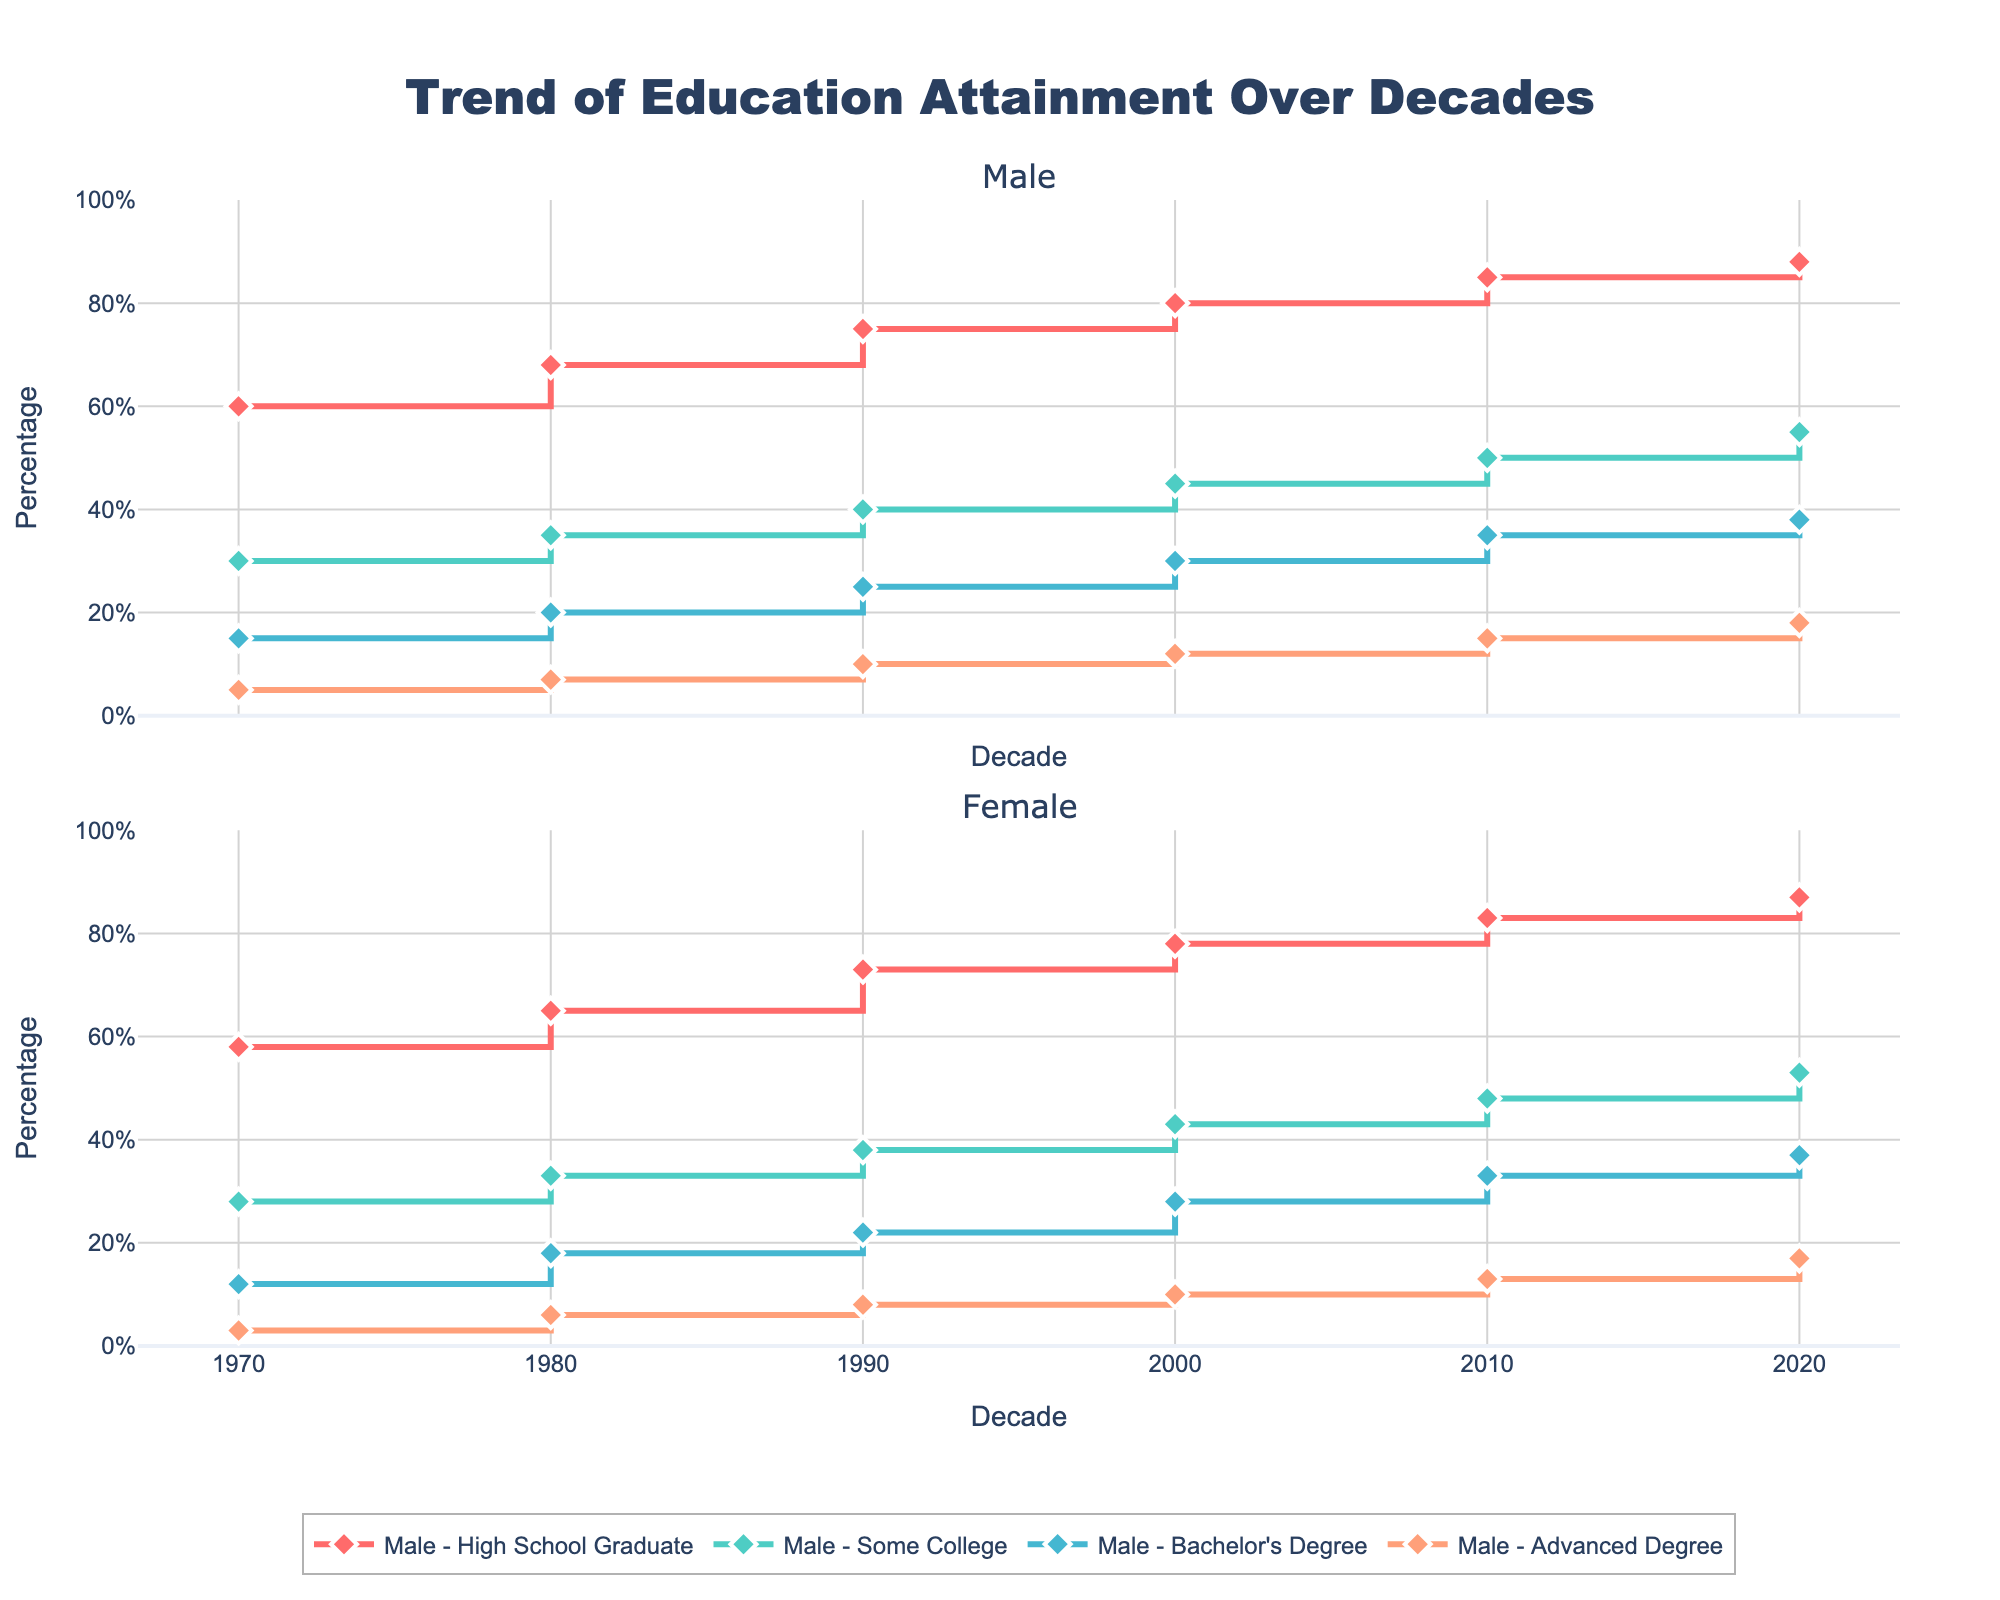What is the title of the figure? The title of the figure is located at the top, centered, and in bold text.
Answer: Trend of Education Attainment Over Decades Which gender showed a higher percentage of High School Graduates in 1970? For the year 1970, the percentage of High School Graduates is plotted for both genders. Male: 60%, Female: 58%.
Answer: Male How does the percentage of males with an Advanced Degree change from 1970 to 2020? Looking at the stair plot for males with Advanced Degrees across the decades, the percentages are 5% (1970), 7% (1980), 10% (1990), 12% (2000), 15% (2010), and 18% (2020). The change is an increasing trend from 5% to 18%.
Answer: It increases by 13% In 2020, which gender has a higher percentage of Some College education, and by how much? In 2020, the plot shows males with 55% and females with 53% for Some College education. The difference is 55% - 53% = 2%.
Answer: Male, by 2% What's the average percentage of females with a Bachelor's Degree in the 1980s and 1990s? For females in the 1980s, the percentage is 18%, and in the 1990s, it is 22%. The average is calculated as (18% + 22%) / 2 = 20%.
Answer: 20% Between 1990 and 2000, which gender had a larger increase in the percentage of Some College education? The plot shows males went from 40% (1990) to 45% (2000), an increase of 5%. Females went from 38% (1990) to 43% (2000), also an increase of 5%.
Answer: Both had the same increase What is the lowest percentage of High School Graduates observed over the decades and which gender does it belong to? Observing the plot, the lowest percentage for High School Graduates is 58% for females in 1970.
Answer: 58%, Female How do the trends for Bachelor's Degree attainment differ between males and females from 1970 to 2020? For both genders, the trend shows an increasing percentage. Males start at 15% (1970) and rise to 38% (2020), while females start at 12% (1970) and rise to 37% (2020). Males consistently have slightly higher percentages until 2020 when females almost catch up.
Answer: Both increase; males slightly higher If you sum the percentages of Advanced Degree attainment for males and females in 2010, what is the result? The figure shows males with 15% and females with 13% for Advanced Degrees in 2010. Summing these, 15% + 13% = 28%.
Answer: 28% Which gender has shown a consistently higher percentage of High School Graduates every decade? Examining the plot, the male percentage of High School Graduates is consistently higher than that of females every decade.
Answer: Male 